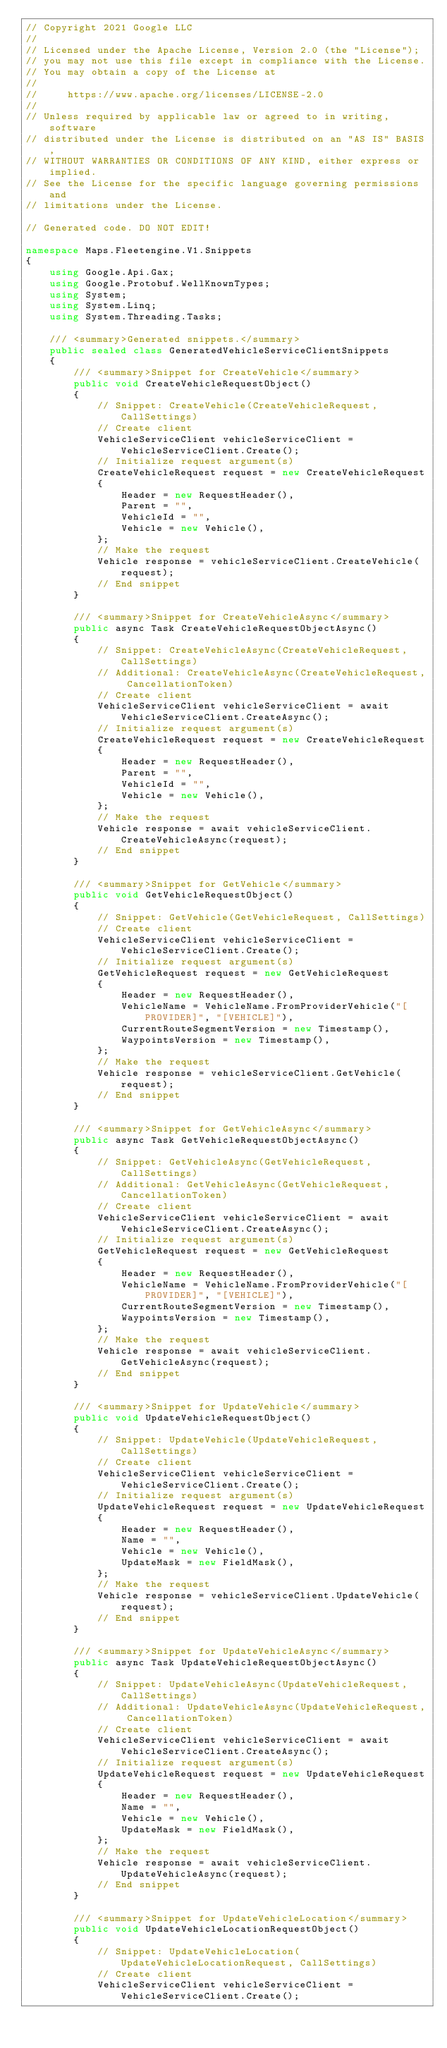<code> <loc_0><loc_0><loc_500><loc_500><_C#_>// Copyright 2021 Google LLC
//
// Licensed under the Apache License, Version 2.0 (the "License");
// you may not use this file except in compliance with the License.
// You may obtain a copy of the License at
//
//     https://www.apache.org/licenses/LICENSE-2.0
//
// Unless required by applicable law or agreed to in writing, software
// distributed under the License is distributed on an "AS IS" BASIS,
// WITHOUT WARRANTIES OR CONDITIONS OF ANY KIND, either express or implied.
// See the License for the specific language governing permissions and
// limitations under the License.

// Generated code. DO NOT EDIT!

namespace Maps.Fleetengine.V1.Snippets
{
    using Google.Api.Gax;
    using Google.Protobuf.WellKnownTypes;
    using System;
    using System.Linq;
    using System.Threading.Tasks;

    /// <summary>Generated snippets.</summary>
    public sealed class GeneratedVehicleServiceClientSnippets
    {
        /// <summary>Snippet for CreateVehicle</summary>
        public void CreateVehicleRequestObject()
        {
            // Snippet: CreateVehicle(CreateVehicleRequest, CallSettings)
            // Create client
            VehicleServiceClient vehicleServiceClient = VehicleServiceClient.Create();
            // Initialize request argument(s)
            CreateVehicleRequest request = new CreateVehicleRequest
            {
                Header = new RequestHeader(),
                Parent = "",
                VehicleId = "",
                Vehicle = new Vehicle(),
            };
            // Make the request
            Vehicle response = vehicleServiceClient.CreateVehicle(request);
            // End snippet
        }

        /// <summary>Snippet for CreateVehicleAsync</summary>
        public async Task CreateVehicleRequestObjectAsync()
        {
            // Snippet: CreateVehicleAsync(CreateVehicleRequest, CallSettings)
            // Additional: CreateVehicleAsync(CreateVehicleRequest, CancellationToken)
            // Create client
            VehicleServiceClient vehicleServiceClient = await VehicleServiceClient.CreateAsync();
            // Initialize request argument(s)
            CreateVehicleRequest request = new CreateVehicleRequest
            {
                Header = new RequestHeader(),
                Parent = "",
                VehicleId = "",
                Vehicle = new Vehicle(),
            };
            // Make the request
            Vehicle response = await vehicleServiceClient.CreateVehicleAsync(request);
            // End snippet
        }

        /// <summary>Snippet for GetVehicle</summary>
        public void GetVehicleRequestObject()
        {
            // Snippet: GetVehicle(GetVehicleRequest, CallSettings)
            // Create client
            VehicleServiceClient vehicleServiceClient = VehicleServiceClient.Create();
            // Initialize request argument(s)
            GetVehicleRequest request = new GetVehicleRequest
            {
                Header = new RequestHeader(),
                VehicleName = VehicleName.FromProviderVehicle("[PROVIDER]", "[VEHICLE]"),
                CurrentRouteSegmentVersion = new Timestamp(),
                WaypointsVersion = new Timestamp(),
            };
            // Make the request
            Vehicle response = vehicleServiceClient.GetVehicle(request);
            // End snippet
        }

        /// <summary>Snippet for GetVehicleAsync</summary>
        public async Task GetVehicleRequestObjectAsync()
        {
            // Snippet: GetVehicleAsync(GetVehicleRequest, CallSettings)
            // Additional: GetVehicleAsync(GetVehicleRequest, CancellationToken)
            // Create client
            VehicleServiceClient vehicleServiceClient = await VehicleServiceClient.CreateAsync();
            // Initialize request argument(s)
            GetVehicleRequest request = new GetVehicleRequest
            {
                Header = new RequestHeader(),
                VehicleName = VehicleName.FromProviderVehicle("[PROVIDER]", "[VEHICLE]"),
                CurrentRouteSegmentVersion = new Timestamp(),
                WaypointsVersion = new Timestamp(),
            };
            // Make the request
            Vehicle response = await vehicleServiceClient.GetVehicleAsync(request);
            // End snippet
        }

        /// <summary>Snippet for UpdateVehicle</summary>
        public void UpdateVehicleRequestObject()
        {
            // Snippet: UpdateVehicle(UpdateVehicleRequest, CallSettings)
            // Create client
            VehicleServiceClient vehicleServiceClient = VehicleServiceClient.Create();
            // Initialize request argument(s)
            UpdateVehicleRequest request = new UpdateVehicleRequest
            {
                Header = new RequestHeader(),
                Name = "",
                Vehicle = new Vehicle(),
                UpdateMask = new FieldMask(),
            };
            // Make the request
            Vehicle response = vehicleServiceClient.UpdateVehicle(request);
            // End snippet
        }

        /// <summary>Snippet for UpdateVehicleAsync</summary>
        public async Task UpdateVehicleRequestObjectAsync()
        {
            // Snippet: UpdateVehicleAsync(UpdateVehicleRequest, CallSettings)
            // Additional: UpdateVehicleAsync(UpdateVehicleRequest, CancellationToken)
            // Create client
            VehicleServiceClient vehicleServiceClient = await VehicleServiceClient.CreateAsync();
            // Initialize request argument(s)
            UpdateVehicleRequest request = new UpdateVehicleRequest
            {
                Header = new RequestHeader(),
                Name = "",
                Vehicle = new Vehicle(),
                UpdateMask = new FieldMask(),
            };
            // Make the request
            Vehicle response = await vehicleServiceClient.UpdateVehicleAsync(request);
            // End snippet
        }

        /// <summary>Snippet for UpdateVehicleLocation</summary>
        public void UpdateVehicleLocationRequestObject()
        {
            // Snippet: UpdateVehicleLocation(UpdateVehicleLocationRequest, CallSettings)
            // Create client
            VehicleServiceClient vehicleServiceClient = VehicleServiceClient.Create();</code> 